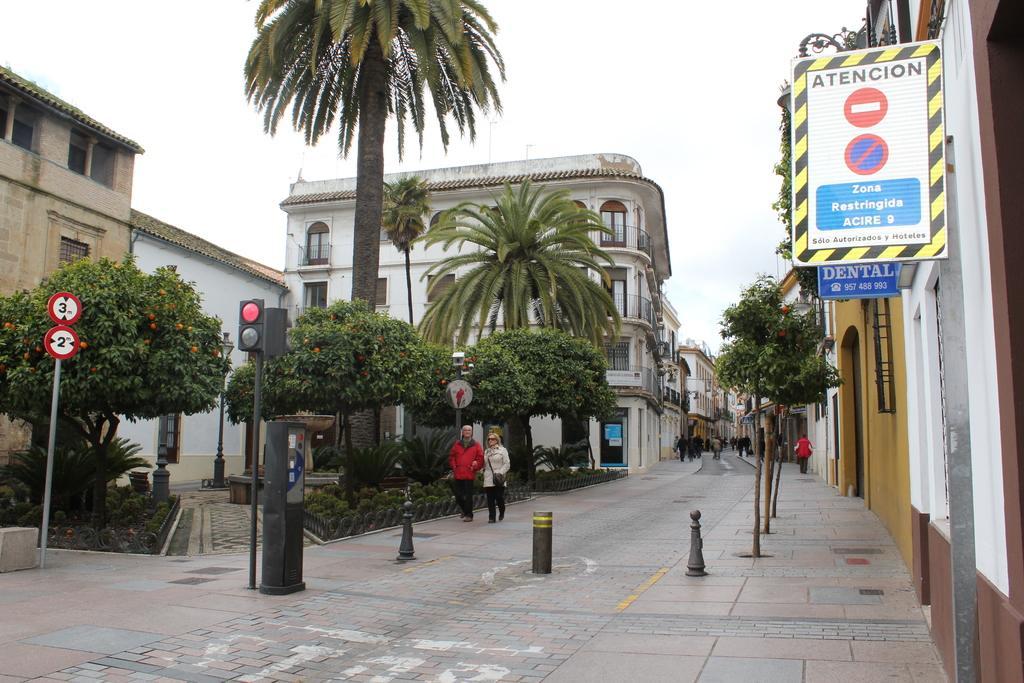Please provide a concise description of this image. This image is clicked on the road. In this image, we can see many persons walking on the road. At the bottom, there is a road. On the left, there are trees and building. On the right, there is a board fixed on the wall of a building. At the top, there is a sky. In the middle, we can see two women walking on the road. 